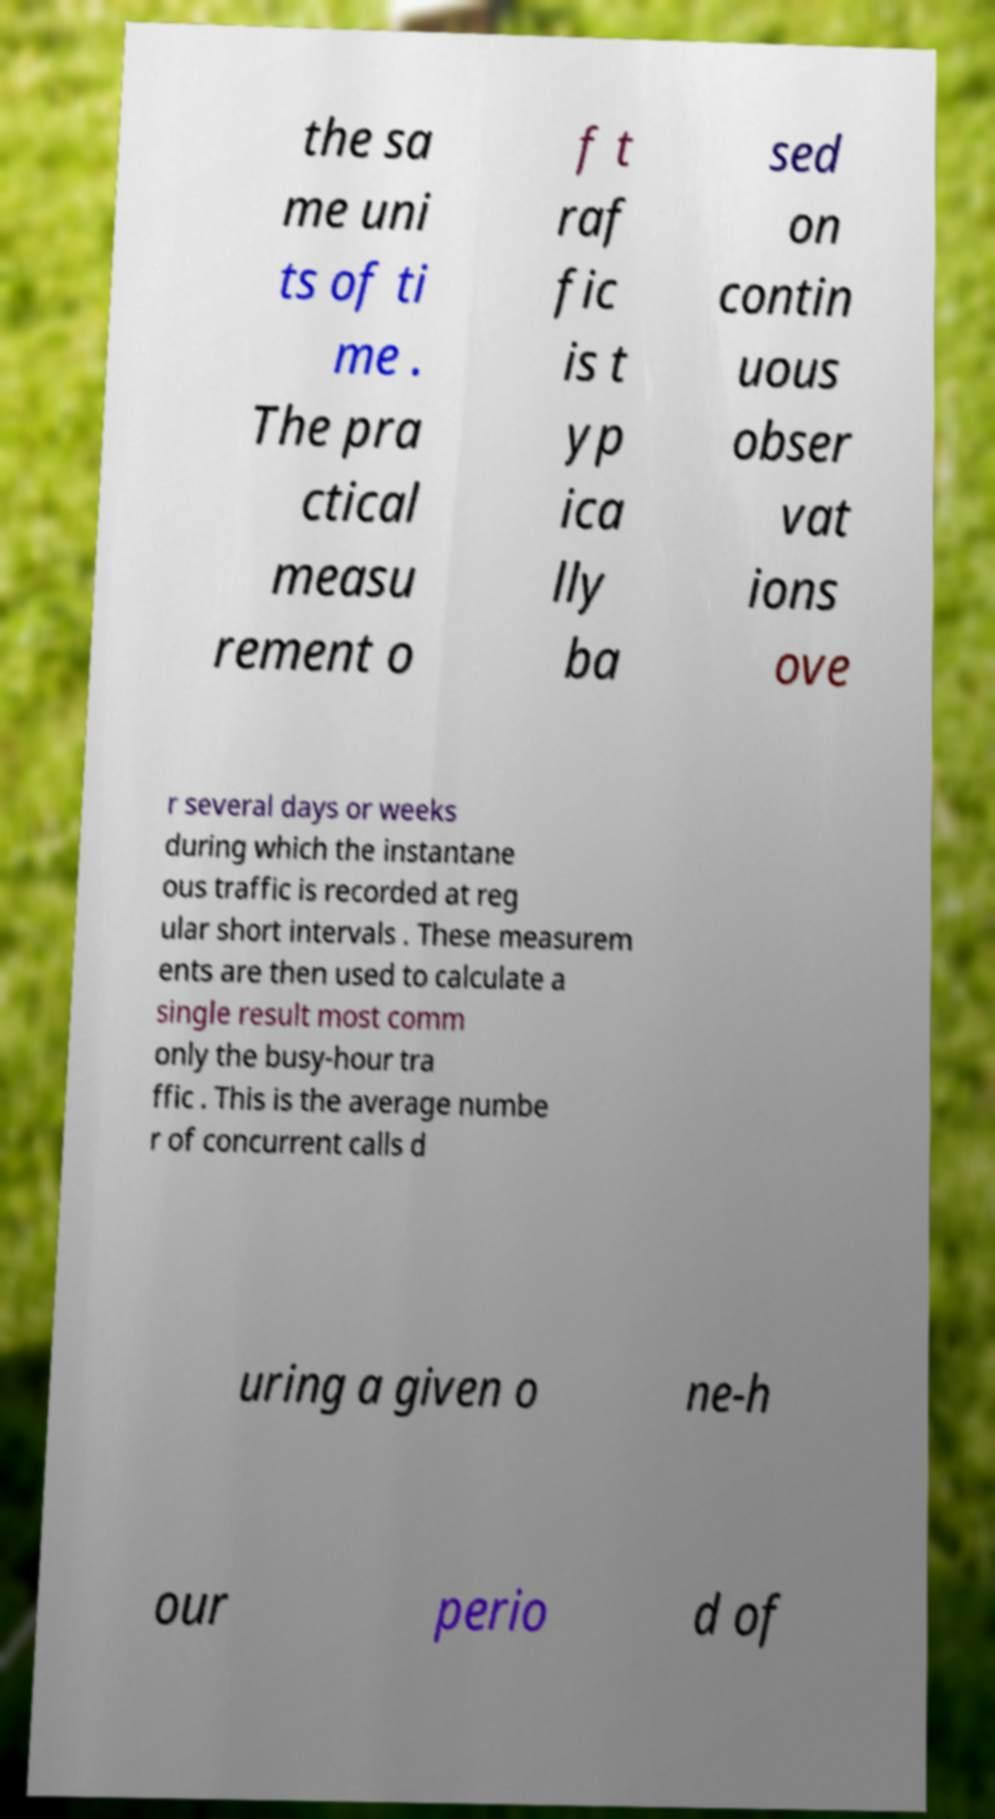For documentation purposes, I need the text within this image transcribed. Could you provide that? the sa me uni ts of ti me . The pra ctical measu rement o f t raf fic is t yp ica lly ba sed on contin uous obser vat ions ove r several days or weeks during which the instantane ous traffic is recorded at reg ular short intervals . These measurem ents are then used to calculate a single result most comm only the busy-hour tra ffic . This is the average numbe r of concurrent calls d uring a given o ne-h our perio d of 